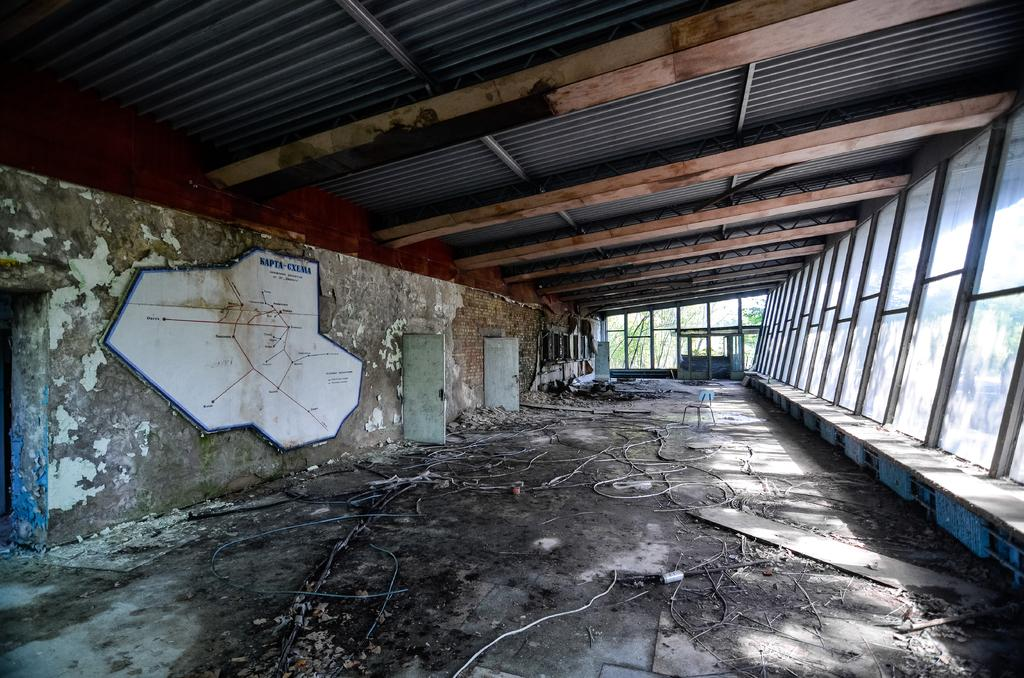Where was the image taken? The image was taken inside an abandoned building. What can be seen hanging in the building? There are wires present in the building. What is visible on the floor in the image? Dust is visible in the building. What is visible on the right side of the image? There are windows on the right side of the image. What material is the ceiling made of? The ceiling is made of iron sheets. Who is the owner of the building in the image? The image does not provide information about the owner of the building. Can you tell me if a stranger is present in the image? There is no indication of a stranger's presence in the image. 